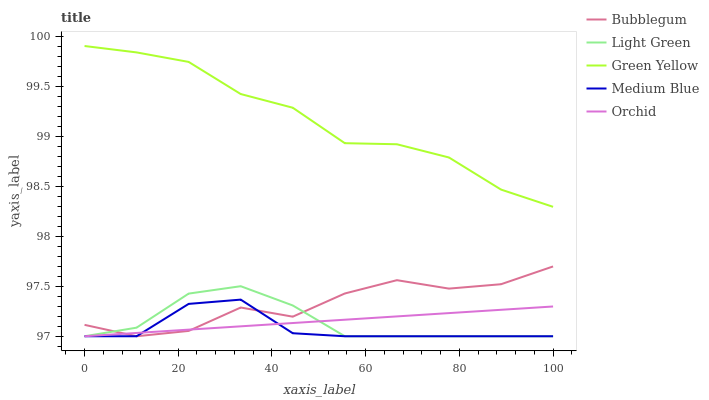Does Medium Blue have the minimum area under the curve?
Answer yes or no. Yes. Does Green Yellow have the maximum area under the curve?
Answer yes or no. Yes. Does Light Green have the minimum area under the curve?
Answer yes or no. No. Does Light Green have the maximum area under the curve?
Answer yes or no. No. Is Orchid the smoothest?
Answer yes or no. Yes. Is Bubblegum the roughest?
Answer yes or no. Yes. Is Medium Blue the smoothest?
Answer yes or no. No. Is Medium Blue the roughest?
Answer yes or no. No. Does Medium Blue have the lowest value?
Answer yes or no. Yes. Does Green Yellow have the highest value?
Answer yes or no. Yes. Does Medium Blue have the highest value?
Answer yes or no. No. Is Medium Blue less than Green Yellow?
Answer yes or no. Yes. Is Green Yellow greater than Orchid?
Answer yes or no. Yes. Does Light Green intersect Orchid?
Answer yes or no. Yes. Is Light Green less than Orchid?
Answer yes or no. No. Is Light Green greater than Orchid?
Answer yes or no. No. Does Medium Blue intersect Green Yellow?
Answer yes or no. No. 